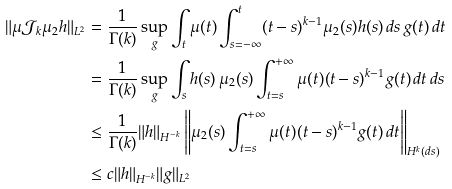<formula> <loc_0><loc_0><loc_500><loc_500>\| \mu \mathcal { J } _ { k } \mu _ { 2 } h \| _ { L ^ { 2 } } & = \frac { 1 } { \Gamma ( k ) } \sup _ { g } \int _ { t } \mu ( t ) \int _ { s = - \infty } ^ { t } ( t - s ) ^ { k - 1 } \mu _ { 2 } ( s ) h ( s ) \, d s \, g ( t ) \, d t \\ & = \frac { 1 } { \Gamma ( k ) } \sup _ { g } \int _ { s } h ( s ) \, \mu _ { 2 } ( s ) \int _ { t = s } ^ { + \infty } \mu ( t ) ( t - s ) ^ { k - 1 } g ( t ) \, d t \, d s \\ & \leq \frac { 1 } { \Gamma ( k ) } \| h \| _ { H ^ { - k } } \left \| \mu _ { 2 } ( s ) \int _ { t = s } ^ { + \infty } \mu ( t ) ( t - s ) ^ { k - 1 } g ( t ) \, d t \right \| _ { H ^ { k } ( d s ) } \\ & \leq c \| h \| _ { H ^ { - k } } \| g \| _ { L ^ { 2 } }</formula> 